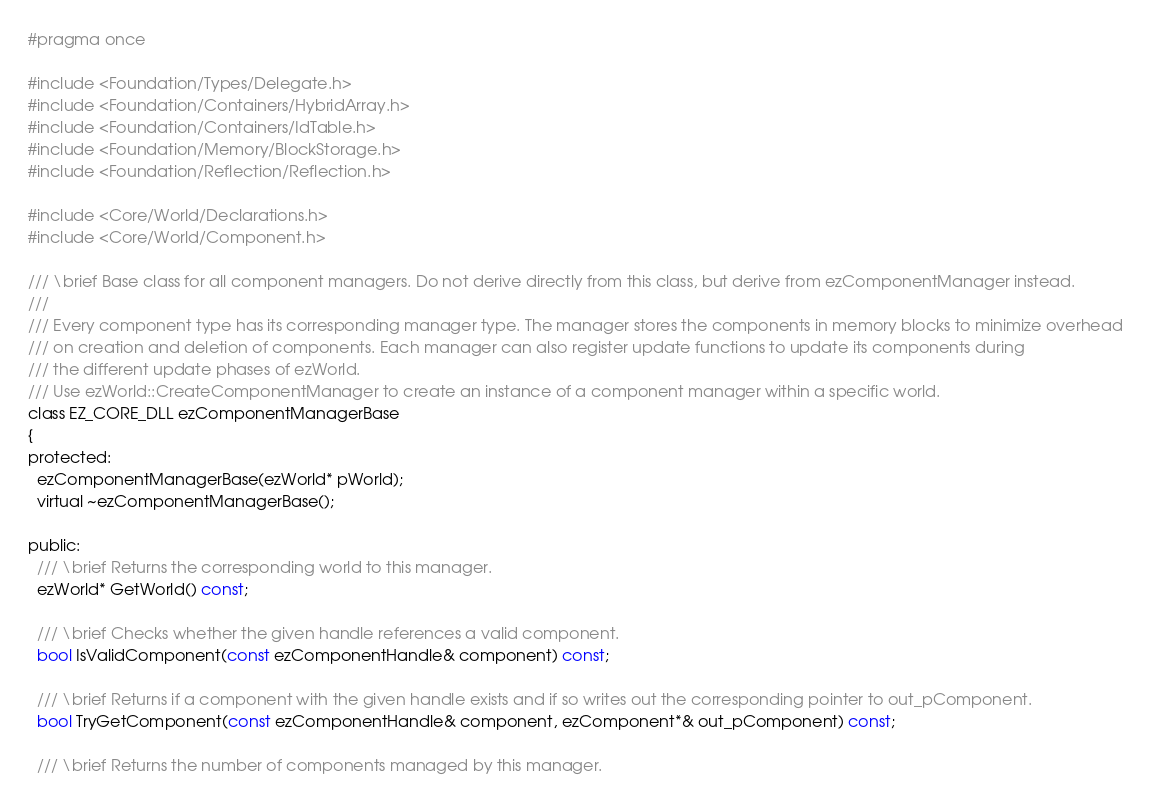Convert code to text. <code><loc_0><loc_0><loc_500><loc_500><_C_>#pragma once

#include <Foundation/Types/Delegate.h>
#include <Foundation/Containers/HybridArray.h>
#include <Foundation/Containers/IdTable.h>
#include <Foundation/Memory/BlockStorage.h>
#include <Foundation/Reflection/Reflection.h>

#include <Core/World/Declarations.h>
#include <Core/World/Component.h>

/// \brief Base class for all component managers. Do not derive directly from this class, but derive from ezComponentManager instead.
///
/// Every component type has its corresponding manager type. The manager stores the components in memory blocks to minimize overhead 
/// on creation and deletion of components. Each manager can also register update functions to update its components during
/// the different update phases of ezWorld.
/// Use ezWorld::CreateComponentManager to create an instance of a component manager within a specific world.
class EZ_CORE_DLL ezComponentManagerBase
{
protected:
  ezComponentManagerBase(ezWorld* pWorld);
  virtual ~ezComponentManagerBase();
  
public:
  /// \brief Returns the corresponding world to this manager.
  ezWorld* GetWorld() const;

  /// \brief Checks whether the given handle references a valid component.
  bool IsValidComponent(const ezComponentHandle& component) const;

  /// \brief Returns if a component with the given handle exists and if so writes out the corresponding pointer to out_pComponent.
  bool TryGetComponent(const ezComponentHandle& component, ezComponent*& out_pComponent) const;

  /// \brief Returns the number of components managed by this manager.</code> 